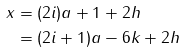Convert formula to latex. <formula><loc_0><loc_0><loc_500><loc_500>x & = ( 2 i ) a + 1 + 2 h \\ & = ( 2 i + 1 ) a - 6 k + 2 h</formula> 